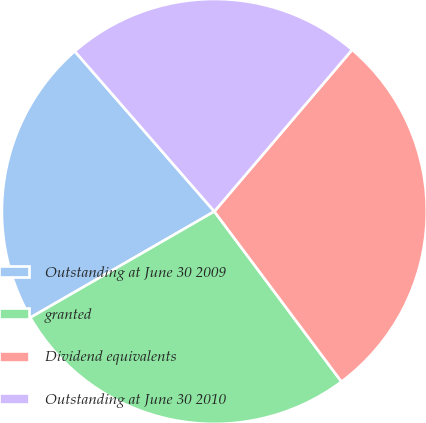Convert chart. <chart><loc_0><loc_0><loc_500><loc_500><pie_chart><fcel>Outstanding at June 30 2009<fcel>granted<fcel>Dividend equivalents<fcel>Outstanding at June 30 2010<nl><fcel>21.92%<fcel>26.88%<fcel>28.56%<fcel>22.64%<nl></chart> 